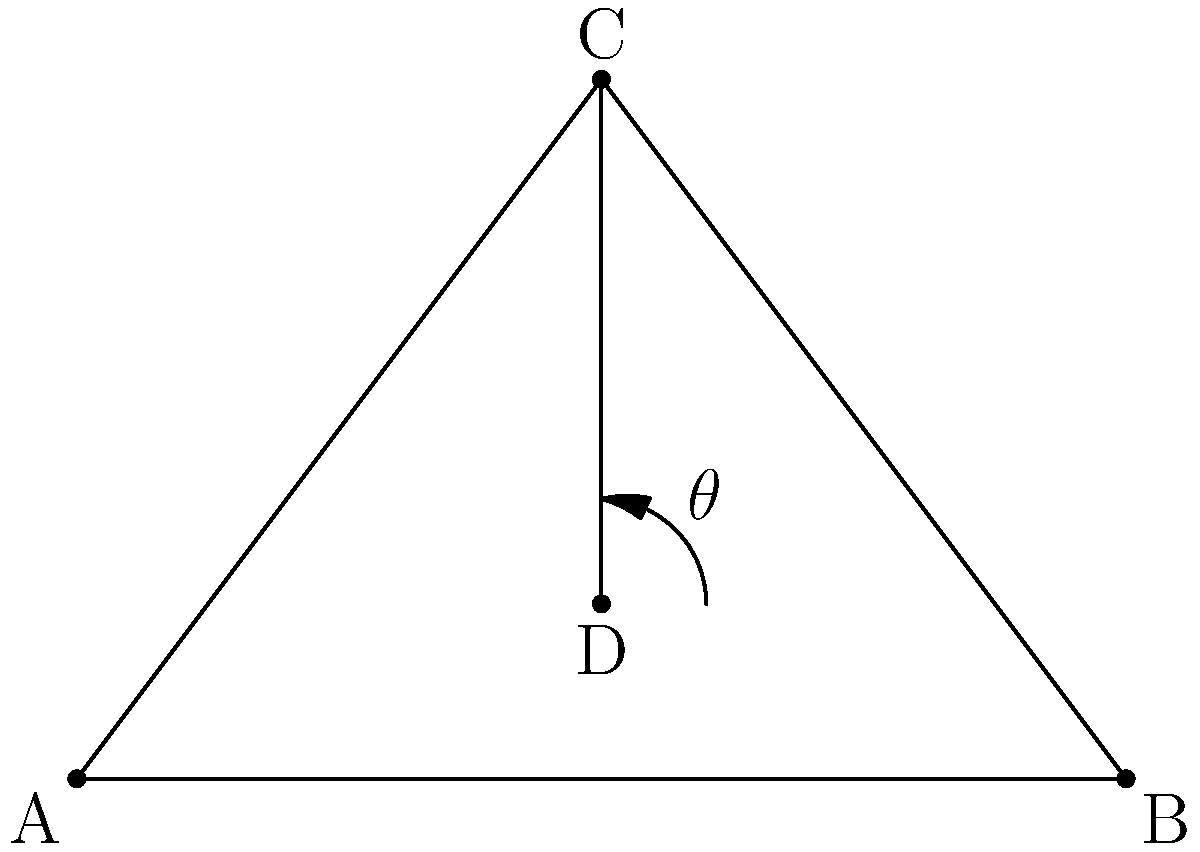While creating traditional Sámi handicrafts, you often sit on the ground with your legs folded. In this position, your upper body forms a triangle ABC as shown in the diagram. Point D represents your hands working on the craft. If the angle $\theta$ between your arms (DC) and your lap (AB) is 60°, and AD = 1.5 units, DB = 1.5 units, what is the length of DC (the distance from your hands to your shoulders) in units? To solve this problem, we'll use trigonometry:

1. The triangle ADB is isosceles since AD = DB = 1.5 units.
2. In the triangle ADC:
   a. We know angle $\theta$ = 60°
   b. We need to find the length of DC

3. In the right triangle ADE (where E is the foot of the perpendicular from C to AB):
   a. $\tan(\theta) = \frac{CE}{DE}$
   b. $\tan(60°) = \frac{CE}{1.5}$
   c. $\sqrt{3} = \frac{CE}{1.5}$
   d. $CE = 1.5\sqrt{3}$

4. Now in the right triangle CDE:
   a. $DC^2 = DE^2 + CE^2$ (Pythagorean theorem)
   b. $DC^2 = 1.5^2 + (1.5\sqrt{3})^2$
   c. $DC^2 = 2.25 + 6.75 = 9$
   d. $DC = 3$

Therefore, the length of DC is 3 units.
Answer: 3 units 